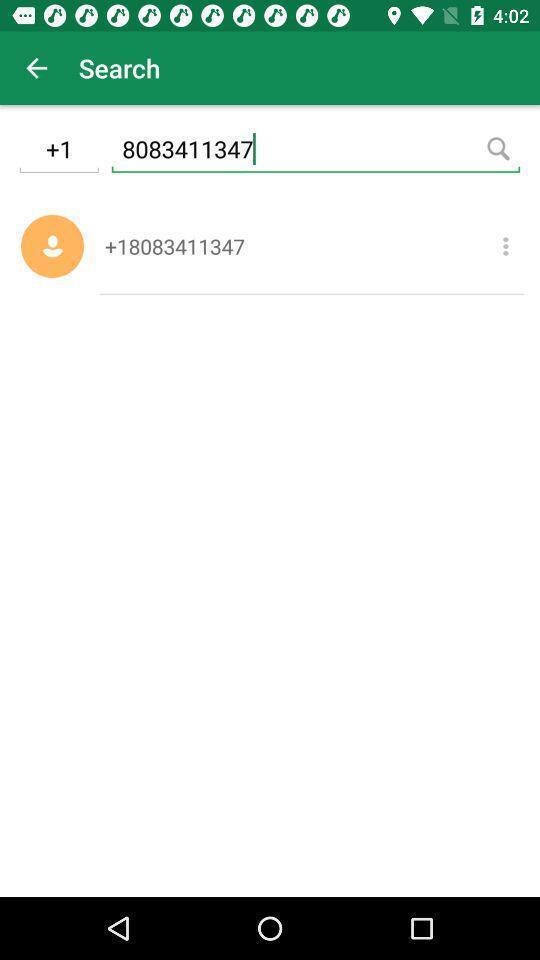What is the overall content of this screenshot? Page showing option of number. 